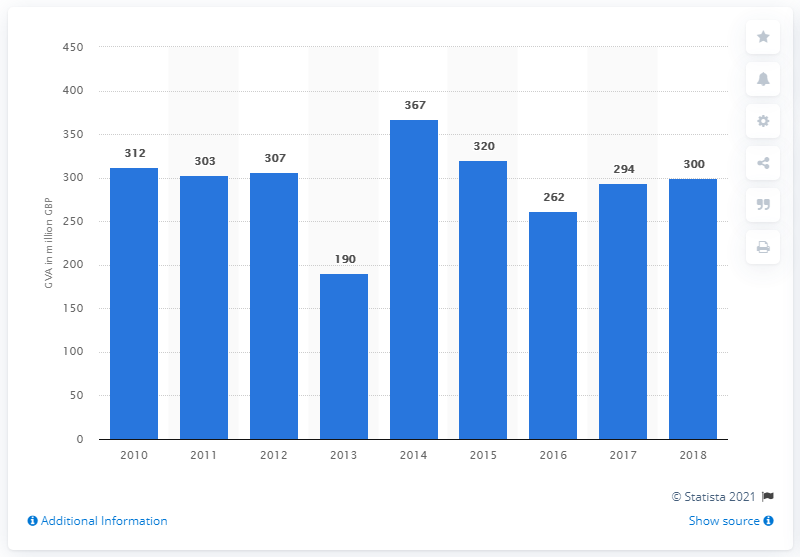Mention a couple of crucial points in this snapshot. The gross value added of the crafts industry in the UK in 2010 was approximately 312 million. In 2018, the year with the lowest value is 110 years after the year 2018. In 2014, the gross value added was 367... In 2018, the gross value added of the crafts industry was approximately $300 million. 